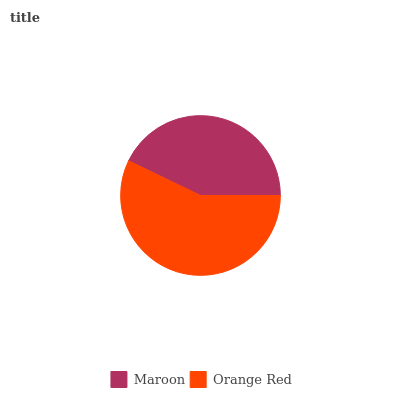Is Maroon the minimum?
Answer yes or no. Yes. Is Orange Red the maximum?
Answer yes or no. Yes. Is Orange Red the minimum?
Answer yes or no. No. Is Orange Red greater than Maroon?
Answer yes or no. Yes. Is Maroon less than Orange Red?
Answer yes or no. Yes. Is Maroon greater than Orange Red?
Answer yes or no. No. Is Orange Red less than Maroon?
Answer yes or no. No. Is Orange Red the high median?
Answer yes or no. Yes. Is Maroon the low median?
Answer yes or no. Yes. Is Maroon the high median?
Answer yes or no. No. Is Orange Red the low median?
Answer yes or no. No. 